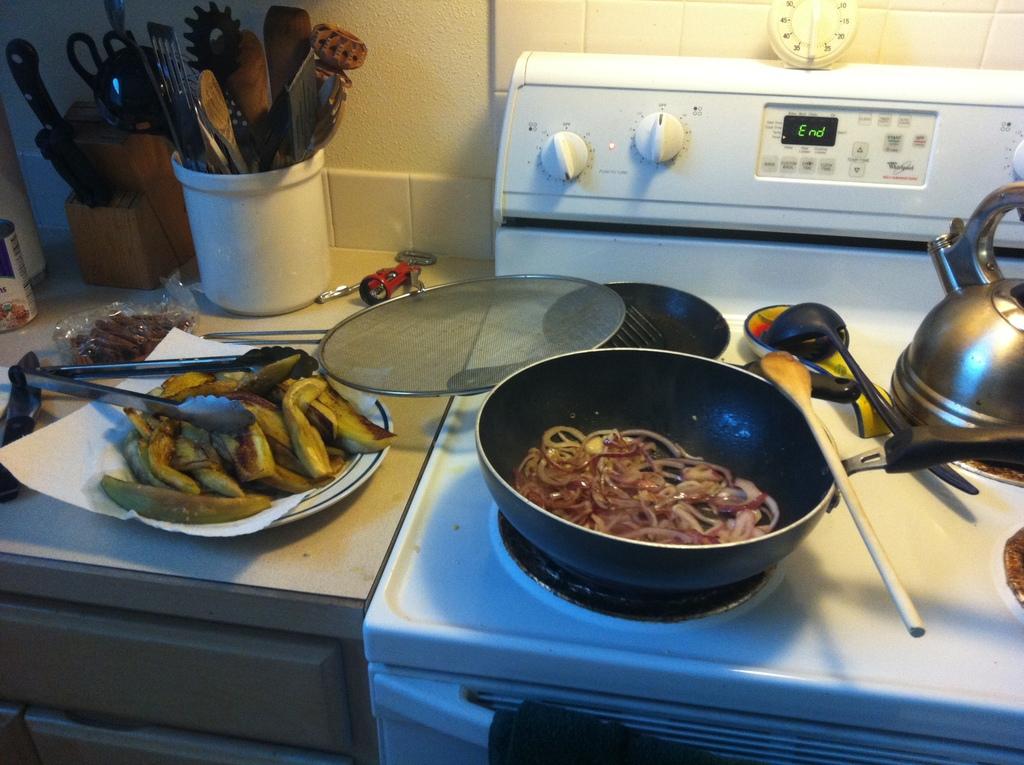What does the oven say that is three letters on its screen?
Make the answer very short. End. What are they frying?
Make the answer very short. Answering does not require reading text in the image. 